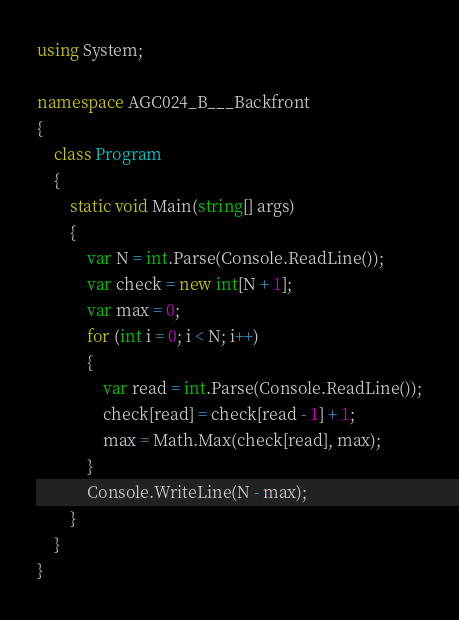Convert code to text. <code><loc_0><loc_0><loc_500><loc_500><_C#_>using System;

namespace AGC024_B___Backfront
{
    class Program
    {
        static void Main(string[] args)
        {
            var N = int.Parse(Console.ReadLine());
            var check = new int[N + 1];
            var max = 0;
            for (int i = 0; i < N; i++)
            {
                var read = int.Parse(Console.ReadLine());
                check[read] = check[read - 1] + 1;
                max = Math.Max(check[read], max);
            }
            Console.WriteLine(N - max);
        }
    }
}
</code> 